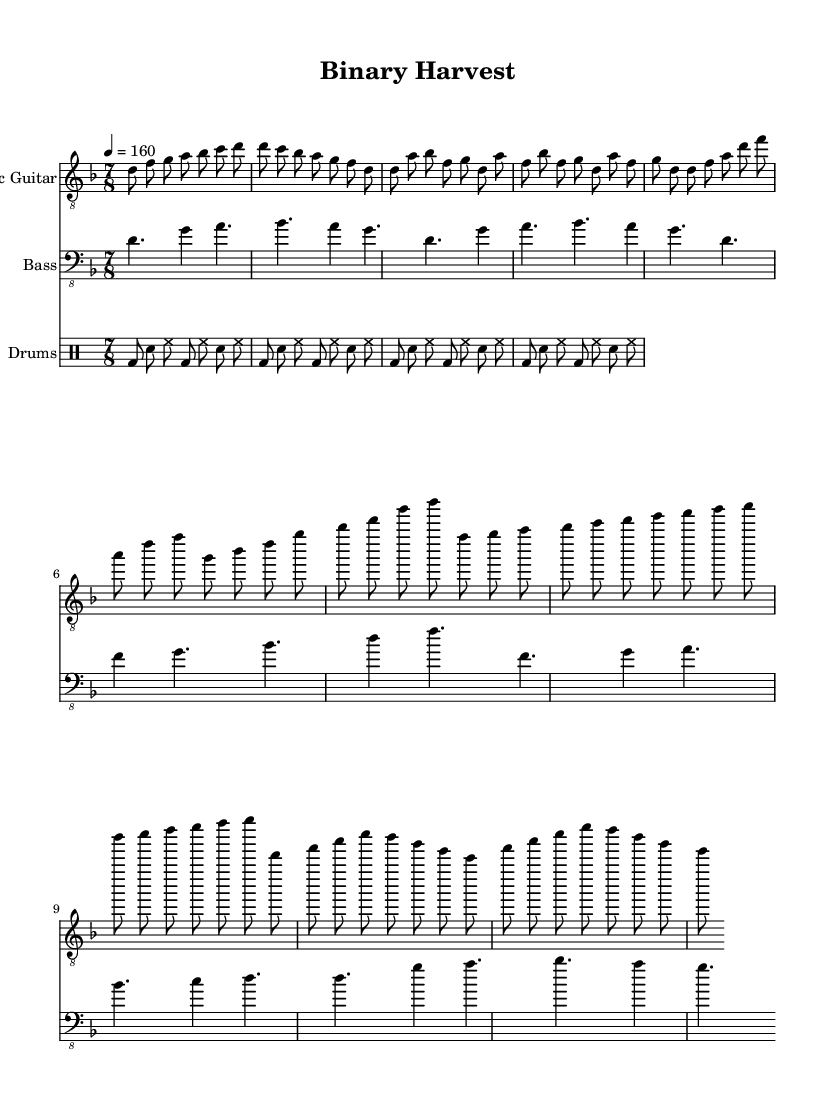What is the key signature of this music? The key signature is indicated at the beginning of the score. Here it shows a D minor key signature, which typically has one flat (B flat) and is denoted by the 'd' in the key area.
Answer: D minor What is the time signature of this music? The time signature is displayed at the beginning of the score right after the key signature. It shows 7/8, meaning there are 7 beats in a measure and the eighth note gets one beat.
Answer: 7/8 What is the tempo marking for this music? The tempo marking is found near the top of the score, indicating how fast the piece should be played. The marking indicates a speed of 160 beats per minute.
Answer: 160 How many measures are in the bridge section? To find the number of measures in the bridge section, I can count the measures of the bridge part specified in the electric guitar and bass guitar sections. The bridge contains 4 measures.
Answer: 4 What is the primary instrument for the solo section? The solo section is primarily indicated in the electric guitar line where specific melody notes are highlighted. Since the electric guitar is typically the lead instrument in metal, it plays the solo part here.
Answer: Electric Guitar What rhythmic pattern is used for the drum part throughout the piece? The drum part features a consistent rhythmic pattern established in the drum section. For each section, it uses bass drum hits (bd), snare drum (sn), and hi-hat (hh) in a repeating cycle. This shows the typical metallic drumming style with a driving rhythm.
Answer: Basic pattern What is the dynamic style suggested for this metal piece? Although there are no explicit dynamics written on the sheet, the fast tempo and hard-picked guitar riffs suggest a heavy and aggressive dynamic style typical of metal music. This can be inferred from the intensity of the notes and the rhythmic patterns.
Answer: Aggressive 